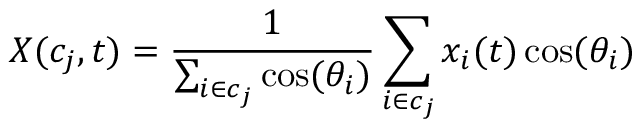Convert formula to latex. <formula><loc_0><loc_0><loc_500><loc_500>X ( c _ { j } , t ) = \frac { 1 } { \sum _ { i \in c _ { j } } \cos ( \theta _ { i } ) } \sum _ { i \in c _ { j } } x _ { i } ( t ) \cos ( \theta _ { i } )</formula> 